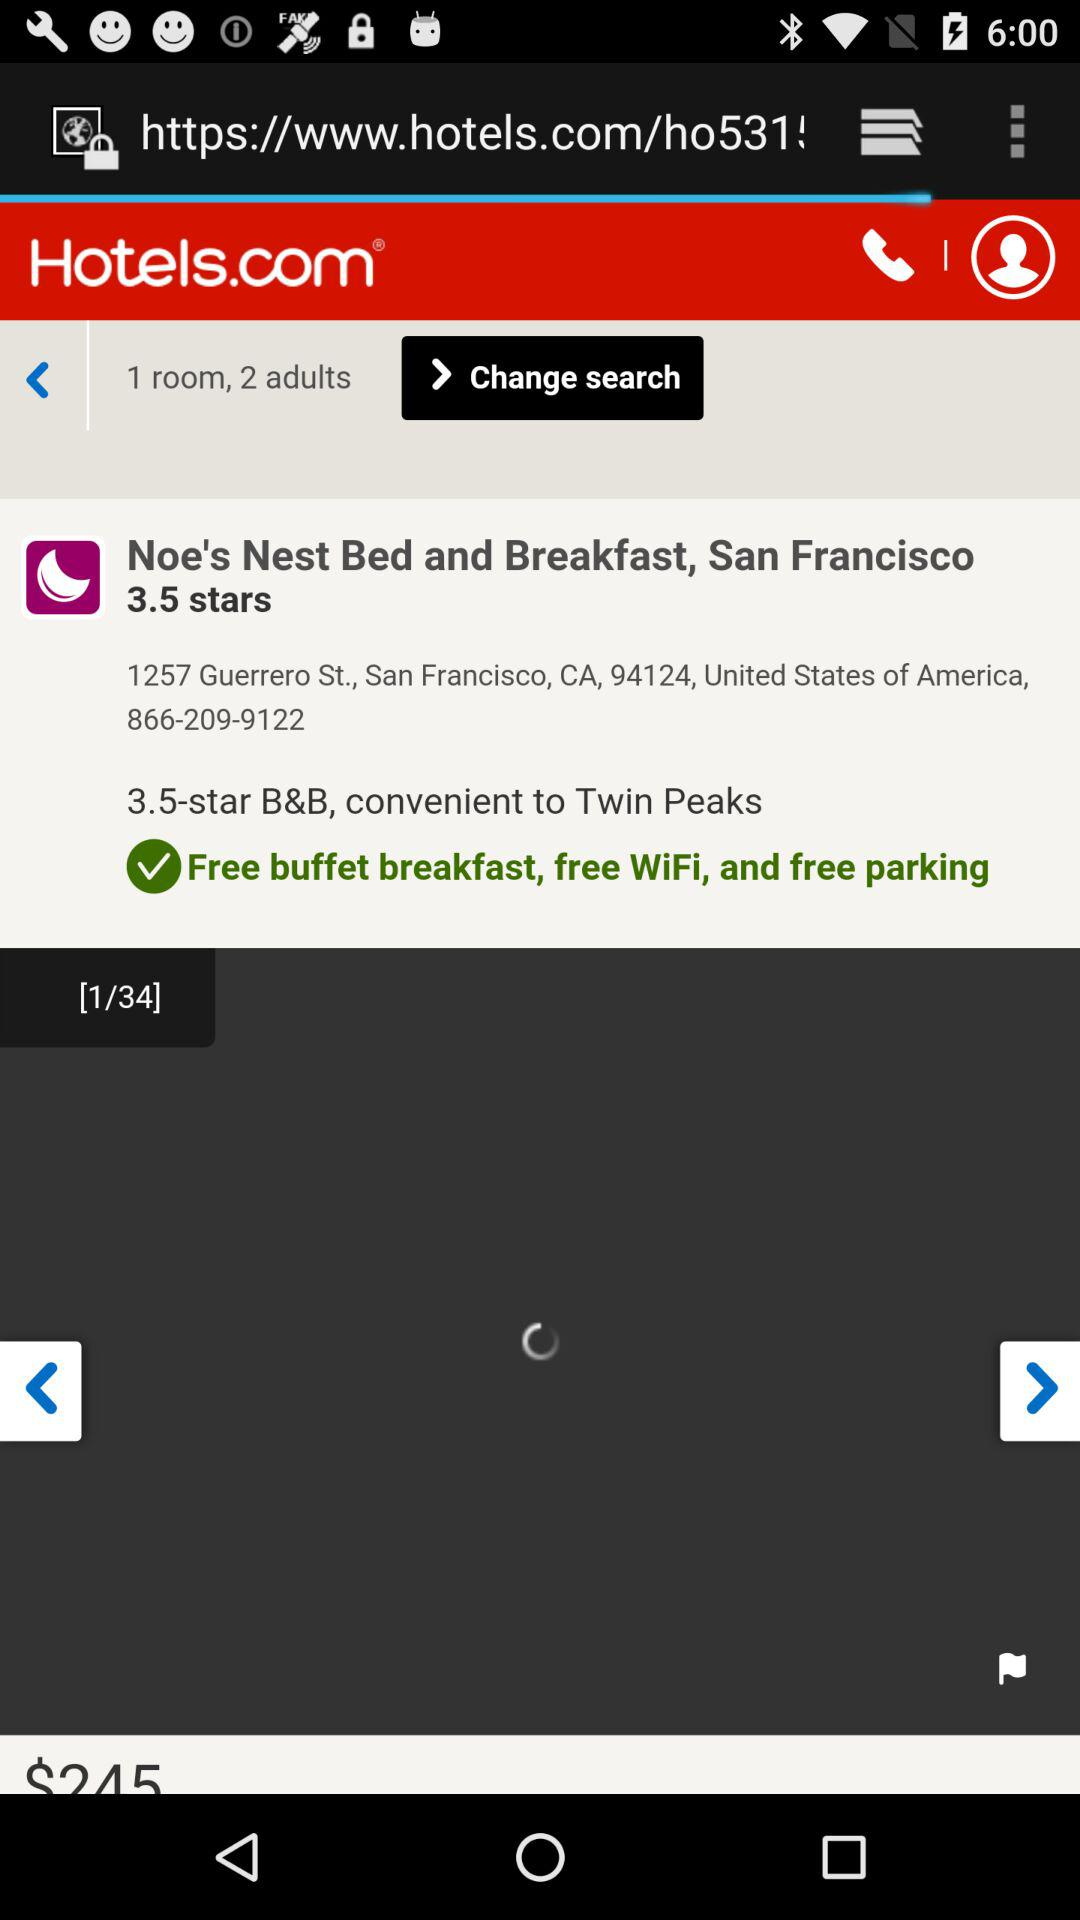What is the rating? The rating is 3.5 stars. 